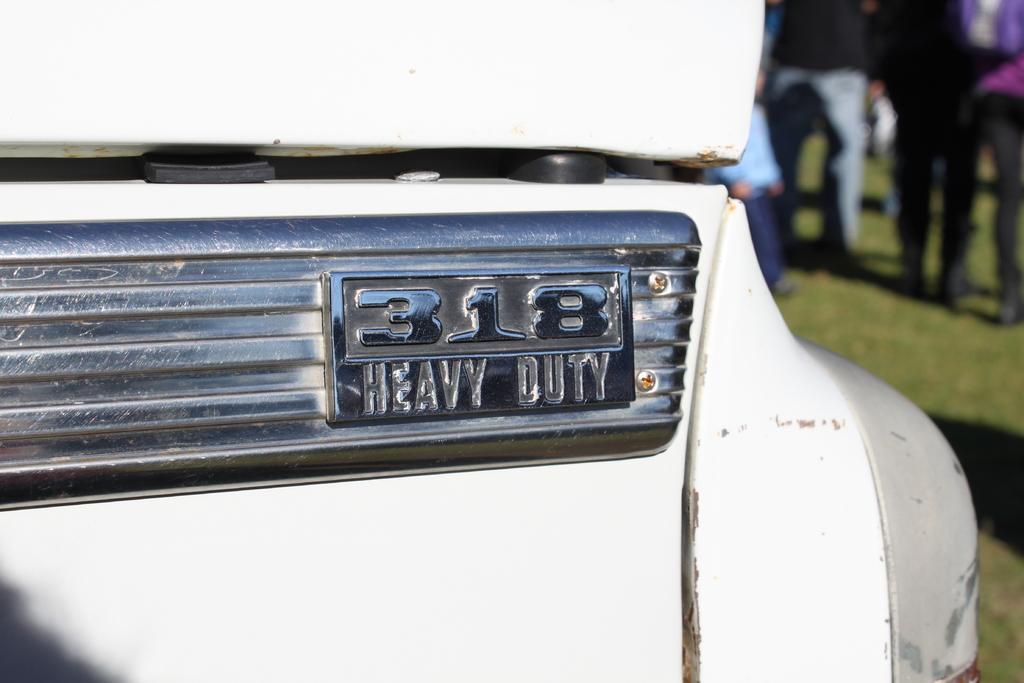Could you give a brief overview of what you see in this image? Picture of a vehicle. Background it is blurry and we can see people. 